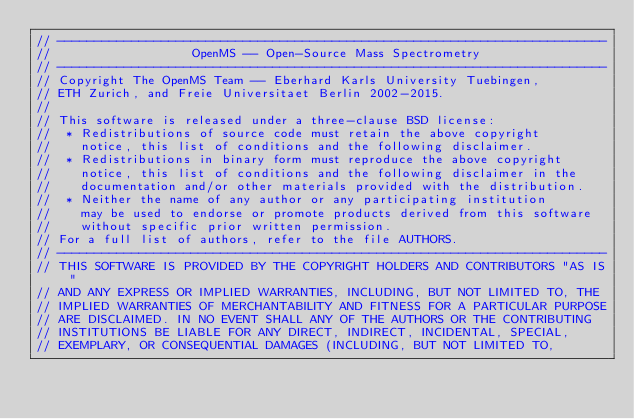<code> <loc_0><loc_0><loc_500><loc_500><_C++_>// --------------------------------------------------------------------------
//                   OpenMS -- Open-Source Mass Spectrometry               
// --------------------------------------------------------------------------
// Copyright The OpenMS Team -- Eberhard Karls University Tuebingen,
// ETH Zurich, and Freie Universitaet Berlin 2002-2015.
// 
// This software is released under a three-clause BSD license:
//  * Redistributions of source code must retain the above copyright
//    notice, this list of conditions and the following disclaimer.
//  * Redistributions in binary form must reproduce the above copyright
//    notice, this list of conditions and the following disclaimer in the
//    documentation and/or other materials provided with the distribution.
//  * Neither the name of any author or any participating institution 
//    may be used to endorse or promote products derived from this software 
//    without specific prior written permission.
// For a full list of authors, refer to the file AUTHORS. 
// --------------------------------------------------------------------------
// THIS SOFTWARE IS PROVIDED BY THE COPYRIGHT HOLDERS AND CONTRIBUTORS "AS IS"
// AND ANY EXPRESS OR IMPLIED WARRANTIES, INCLUDING, BUT NOT LIMITED TO, THE
// IMPLIED WARRANTIES OF MERCHANTABILITY AND FITNESS FOR A PARTICULAR PURPOSE
// ARE DISCLAIMED. IN NO EVENT SHALL ANY OF THE AUTHORS OR THE CONTRIBUTING 
// INSTITUTIONS BE LIABLE FOR ANY DIRECT, INDIRECT, INCIDENTAL, SPECIAL, 
// EXEMPLARY, OR CONSEQUENTIAL DAMAGES (INCLUDING, BUT NOT LIMITED TO, </code> 